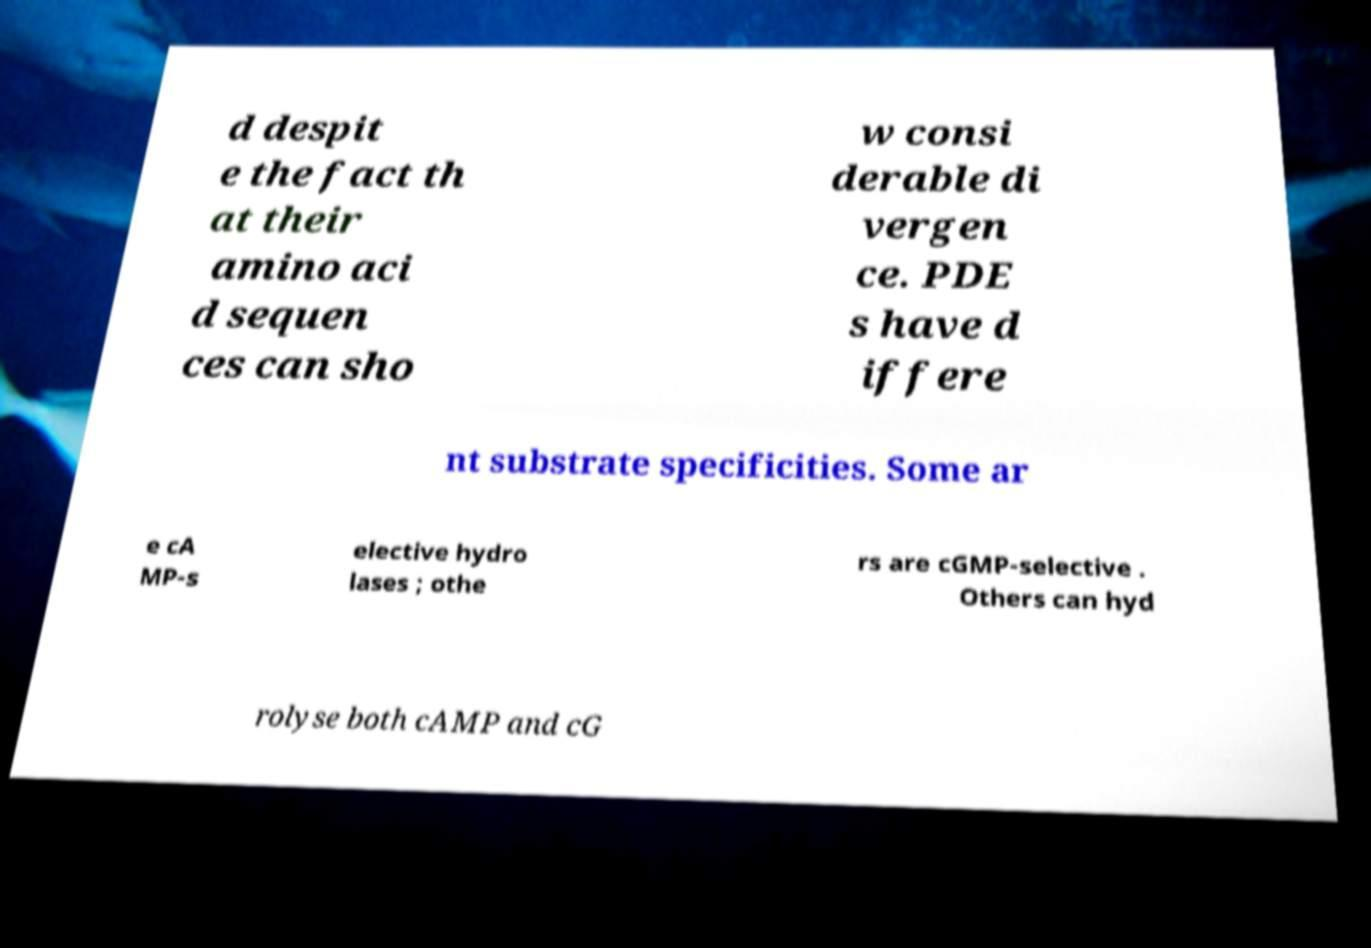Can you accurately transcribe the text from the provided image for me? d despit e the fact th at their amino aci d sequen ces can sho w consi derable di vergen ce. PDE s have d iffere nt substrate specificities. Some ar e cA MP-s elective hydro lases ; othe rs are cGMP-selective . Others can hyd rolyse both cAMP and cG 